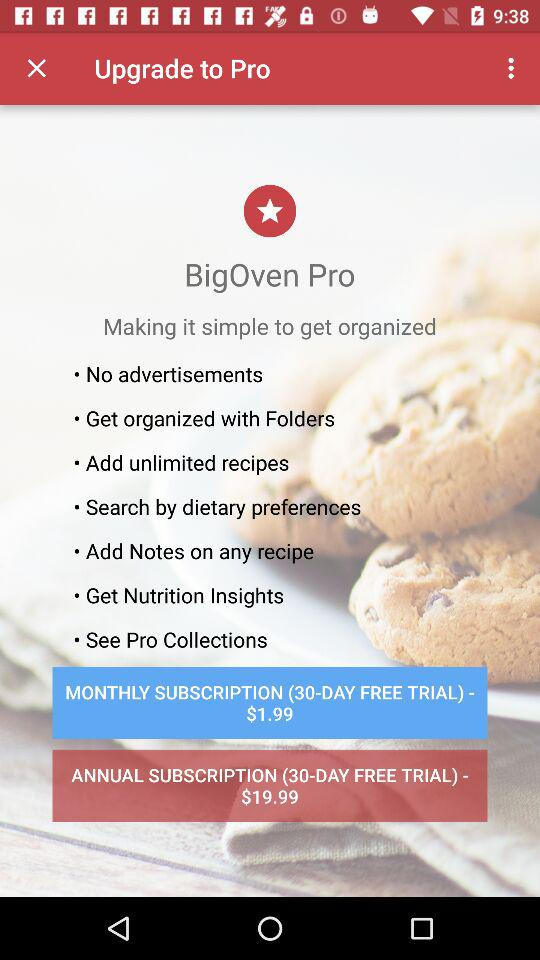How many days of a free trial are there? The free trial is for 30 days. 